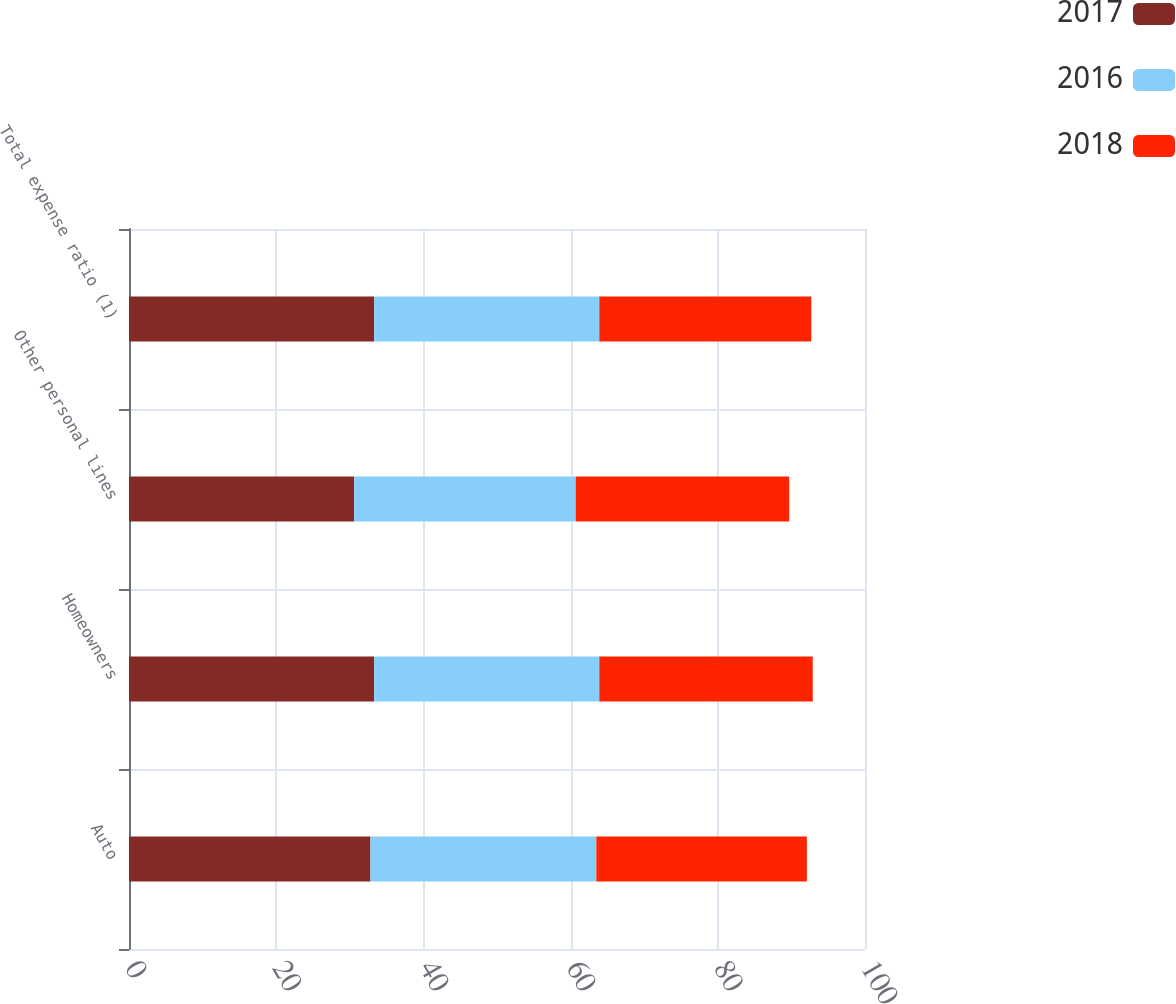Convert chart. <chart><loc_0><loc_0><loc_500><loc_500><stacked_bar_chart><ecel><fcel>Auto<fcel>Homeowners<fcel>Other personal lines<fcel>Total expense ratio (1)<nl><fcel>2017<fcel>32.8<fcel>33.3<fcel>30.6<fcel>33.3<nl><fcel>2016<fcel>30.7<fcel>30.6<fcel>30.1<fcel>30.6<nl><fcel>2018<fcel>28.6<fcel>29<fcel>29<fcel>28.8<nl></chart> 